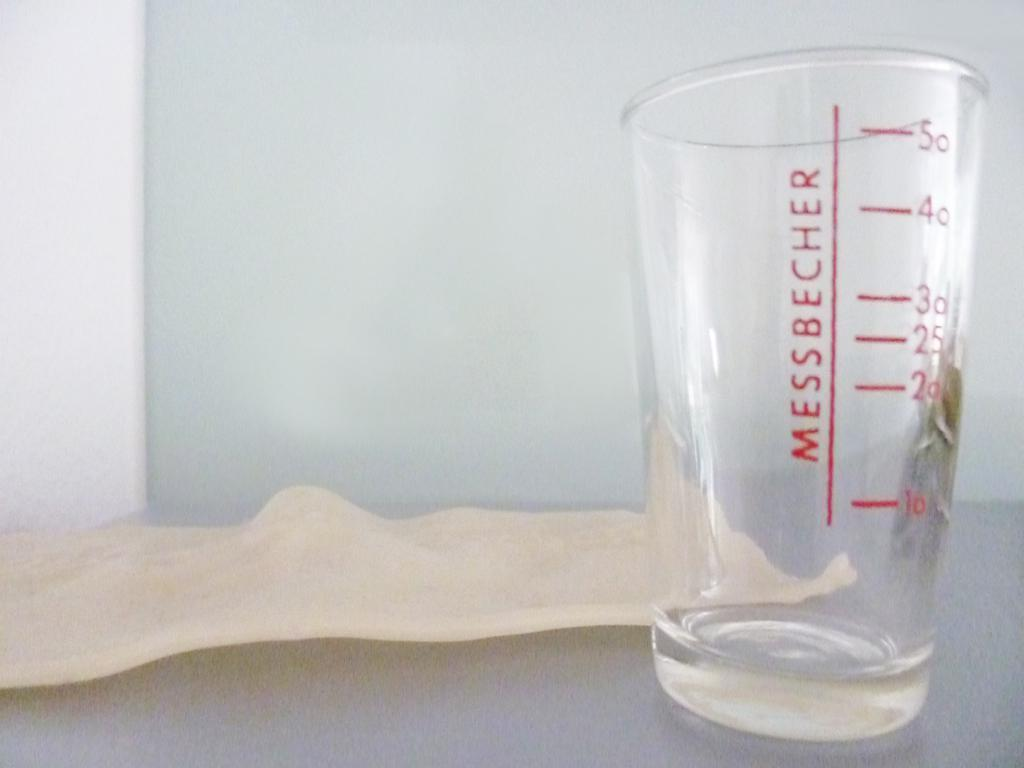<image>
Give a short and clear explanation of the subsequent image. a clear glass with red measurement markings and the name Messbecher is on a coutner 